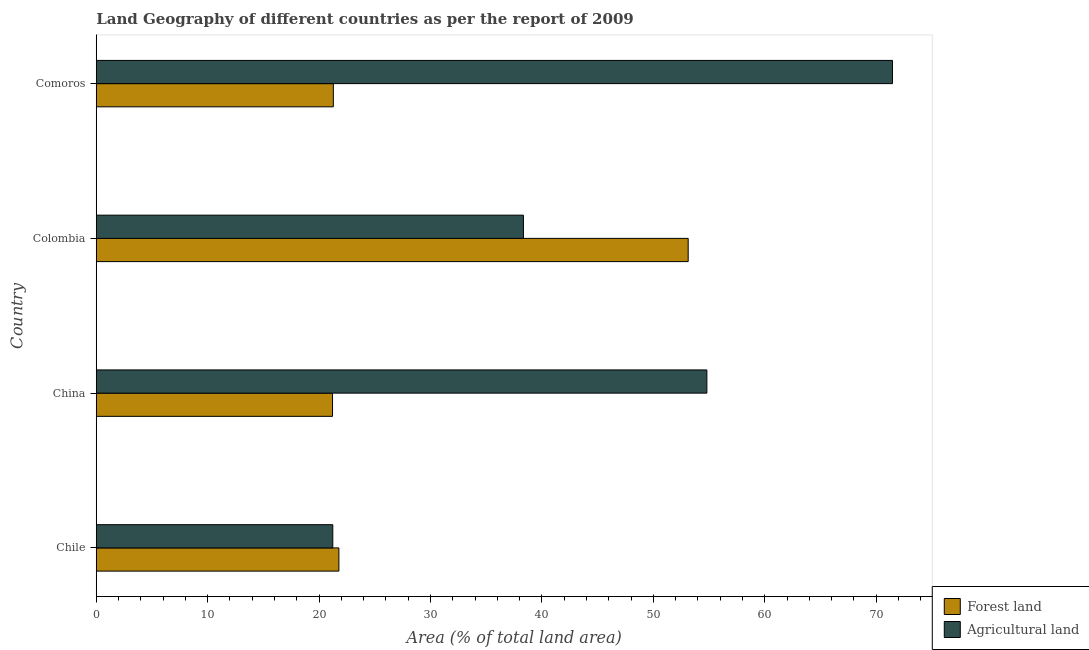How many different coloured bars are there?
Provide a succinct answer. 2. How many bars are there on the 2nd tick from the bottom?
Give a very brief answer. 2. What is the label of the 1st group of bars from the top?
Provide a succinct answer. Comoros. In how many cases, is the number of bars for a given country not equal to the number of legend labels?
Offer a very short reply. 0. What is the percentage of land area under forests in China?
Offer a very short reply. 21.21. Across all countries, what is the maximum percentage of land area under forests?
Your answer should be very brief. 53.13. Across all countries, what is the minimum percentage of land area under forests?
Your answer should be compact. 21.21. In which country was the percentage of land area under forests maximum?
Keep it short and to the point. Colombia. What is the total percentage of land area under forests in the graph?
Provide a short and direct response. 117.4. What is the difference between the percentage of land area under forests in Colombia and that in Comoros?
Make the answer very short. 31.85. What is the difference between the percentage of land area under agriculture in China and the percentage of land area under forests in Colombia?
Your response must be concise. 1.68. What is the average percentage of land area under forests per country?
Offer a terse response. 29.35. What is the difference between the percentage of land area under forests and percentage of land area under agriculture in China?
Keep it short and to the point. -33.6. What is the ratio of the percentage of land area under agriculture in Chile to that in Comoros?
Offer a very short reply. 0.3. Is the difference between the percentage of land area under agriculture in Chile and China greater than the difference between the percentage of land area under forests in Chile and China?
Provide a short and direct response. No. What is the difference between the highest and the second highest percentage of land area under agriculture?
Keep it short and to the point. 16.66. What is the difference between the highest and the lowest percentage of land area under forests?
Your answer should be compact. 31.92. In how many countries, is the percentage of land area under forests greater than the average percentage of land area under forests taken over all countries?
Provide a short and direct response. 1. What does the 2nd bar from the top in Comoros represents?
Offer a very short reply. Forest land. What does the 1st bar from the bottom in China represents?
Offer a very short reply. Forest land. How many bars are there?
Give a very brief answer. 8. How many countries are there in the graph?
Keep it short and to the point. 4. What is the difference between two consecutive major ticks on the X-axis?
Offer a very short reply. 10. Does the graph contain any zero values?
Your answer should be compact. No. Where does the legend appear in the graph?
Your response must be concise. Bottom right. How are the legend labels stacked?
Ensure brevity in your answer.  Vertical. What is the title of the graph?
Your response must be concise. Land Geography of different countries as per the report of 2009. Does "Malaria" appear as one of the legend labels in the graph?
Give a very brief answer. No. What is the label or title of the X-axis?
Your response must be concise. Area (% of total land area). What is the label or title of the Y-axis?
Make the answer very short. Country. What is the Area (% of total land area) in Forest land in Chile?
Give a very brief answer. 21.78. What is the Area (% of total land area) of Agricultural land in Chile?
Your response must be concise. 21.23. What is the Area (% of total land area) in Forest land in China?
Give a very brief answer. 21.21. What is the Area (% of total land area) in Agricultural land in China?
Your answer should be very brief. 54.81. What is the Area (% of total land area) of Forest land in Colombia?
Provide a succinct answer. 53.13. What is the Area (% of total land area) of Agricultural land in Colombia?
Ensure brevity in your answer.  38.34. What is the Area (% of total land area) of Forest land in Comoros?
Offer a terse response. 21.28. What is the Area (% of total land area) in Agricultural land in Comoros?
Give a very brief answer. 71.47. Across all countries, what is the maximum Area (% of total land area) in Forest land?
Give a very brief answer. 53.13. Across all countries, what is the maximum Area (% of total land area) of Agricultural land?
Give a very brief answer. 71.47. Across all countries, what is the minimum Area (% of total land area) in Forest land?
Your answer should be compact. 21.21. Across all countries, what is the minimum Area (% of total land area) in Agricultural land?
Provide a succinct answer. 21.23. What is the total Area (% of total land area) in Forest land in the graph?
Keep it short and to the point. 117.4. What is the total Area (% of total land area) in Agricultural land in the graph?
Your answer should be compact. 185.85. What is the difference between the Area (% of total land area) of Forest land in Chile and that in China?
Offer a very short reply. 0.57. What is the difference between the Area (% of total land area) in Agricultural land in Chile and that in China?
Make the answer very short. -33.58. What is the difference between the Area (% of total land area) of Forest land in Chile and that in Colombia?
Make the answer very short. -31.35. What is the difference between the Area (% of total land area) in Agricultural land in Chile and that in Colombia?
Your response must be concise. -17.11. What is the difference between the Area (% of total land area) in Forest land in Chile and that in Comoros?
Keep it short and to the point. 0.5. What is the difference between the Area (% of total land area) of Agricultural land in Chile and that in Comoros?
Your response must be concise. -50.24. What is the difference between the Area (% of total land area) of Forest land in China and that in Colombia?
Ensure brevity in your answer.  -31.92. What is the difference between the Area (% of total land area) of Agricultural land in China and that in Colombia?
Offer a very short reply. 16.47. What is the difference between the Area (% of total land area) in Forest land in China and that in Comoros?
Your answer should be very brief. -0.07. What is the difference between the Area (% of total land area) in Agricultural land in China and that in Comoros?
Make the answer very short. -16.66. What is the difference between the Area (% of total land area) of Forest land in Colombia and that in Comoros?
Your response must be concise. 31.85. What is the difference between the Area (% of total land area) of Agricultural land in Colombia and that in Comoros?
Make the answer very short. -33.13. What is the difference between the Area (% of total land area) in Forest land in Chile and the Area (% of total land area) in Agricultural land in China?
Your answer should be compact. -33.03. What is the difference between the Area (% of total land area) in Forest land in Chile and the Area (% of total land area) in Agricultural land in Colombia?
Make the answer very short. -16.56. What is the difference between the Area (% of total land area) of Forest land in Chile and the Area (% of total land area) of Agricultural land in Comoros?
Offer a terse response. -49.69. What is the difference between the Area (% of total land area) of Forest land in China and the Area (% of total land area) of Agricultural land in Colombia?
Give a very brief answer. -17.13. What is the difference between the Area (% of total land area) of Forest land in China and the Area (% of total land area) of Agricultural land in Comoros?
Offer a very short reply. -50.26. What is the difference between the Area (% of total land area) in Forest land in Colombia and the Area (% of total land area) in Agricultural land in Comoros?
Provide a short and direct response. -18.34. What is the average Area (% of total land area) of Forest land per country?
Make the answer very short. 29.35. What is the average Area (% of total land area) in Agricultural land per country?
Your response must be concise. 46.46. What is the difference between the Area (% of total land area) in Forest land and Area (% of total land area) in Agricultural land in Chile?
Your response must be concise. 0.55. What is the difference between the Area (% of total land area) of Forest land and Area (% of total land area) of Agricultural land in China?
Ensure brevity in your answer.  -33.6. What is the difference between the Area (% of total land area) in Forest land and Area (% of total land area) in Agricultural land in Colombia?
Offer a very short reply. 14.79. What is the difference between the Area (% of total land area) of Forest land and Area (% of total land area) of Agricultural land in Comoros?
Offer a terse response. -50.19. What is the ratio of the Area (% of total land area) of Agricultural land in Chile to that in China?
Your answer should be very brief. 0.39. What is the ratio of the Area (% of total land area) in Forest land in Chile to that in Colombia?
Your answer should be compact. 0.41. What is the ratio of the Area (% of total land area) in Agricultural land in Chile to that in Colombia?
Ensure brevity in your answer.  0.55. What is the ratio of the Area (% of total land area) in Forest land in Chile to that in Comoros?
Ensure brevity in your answer.  1.02. What is the ratio of the Area (% of total land area) in Agricultural land in Chile to that in Comoros?
Your answer should be compact. 0.3. What is the ratio of the Area (% of total land area) of Forest land in China to that in Colombia?
Make the answer very short. 0.4. What is the ratio of the Area (% of total land area) of Agricultural land in China to that in Colombia?
Offer a terse response. 1.43. What is the ratio of the Area (% of total land area) of Agricultural land in China to that in Comoros?
Make the answer very short. 0.77. What is the ratio of the Area (% of total land area) of Forest land in Colombia to that in Comoros?
Your response must be concise. 2.5. What is the ratio of the Area (% of total land area) in Agricultural land in Colombia to that in Comoros?
Offer a terse response. 0.54. What is the difference between the highest and the second highest Area (% of total land area) in Forest land?
Make the answer very short. 31.35. What is the difference between the highest and the second highest Area (% of total land area) of Agricultural land?
Ensure brevity in your answer.  16.66. What is the difference between the highest and the lowest Area (% of total land area) in Forest land?
Give a very brief answer. 31.92. What is the difference between the highest and the lowest Area (% of total land area) in Agricultural land?
Make the answer very short. 50.24. 